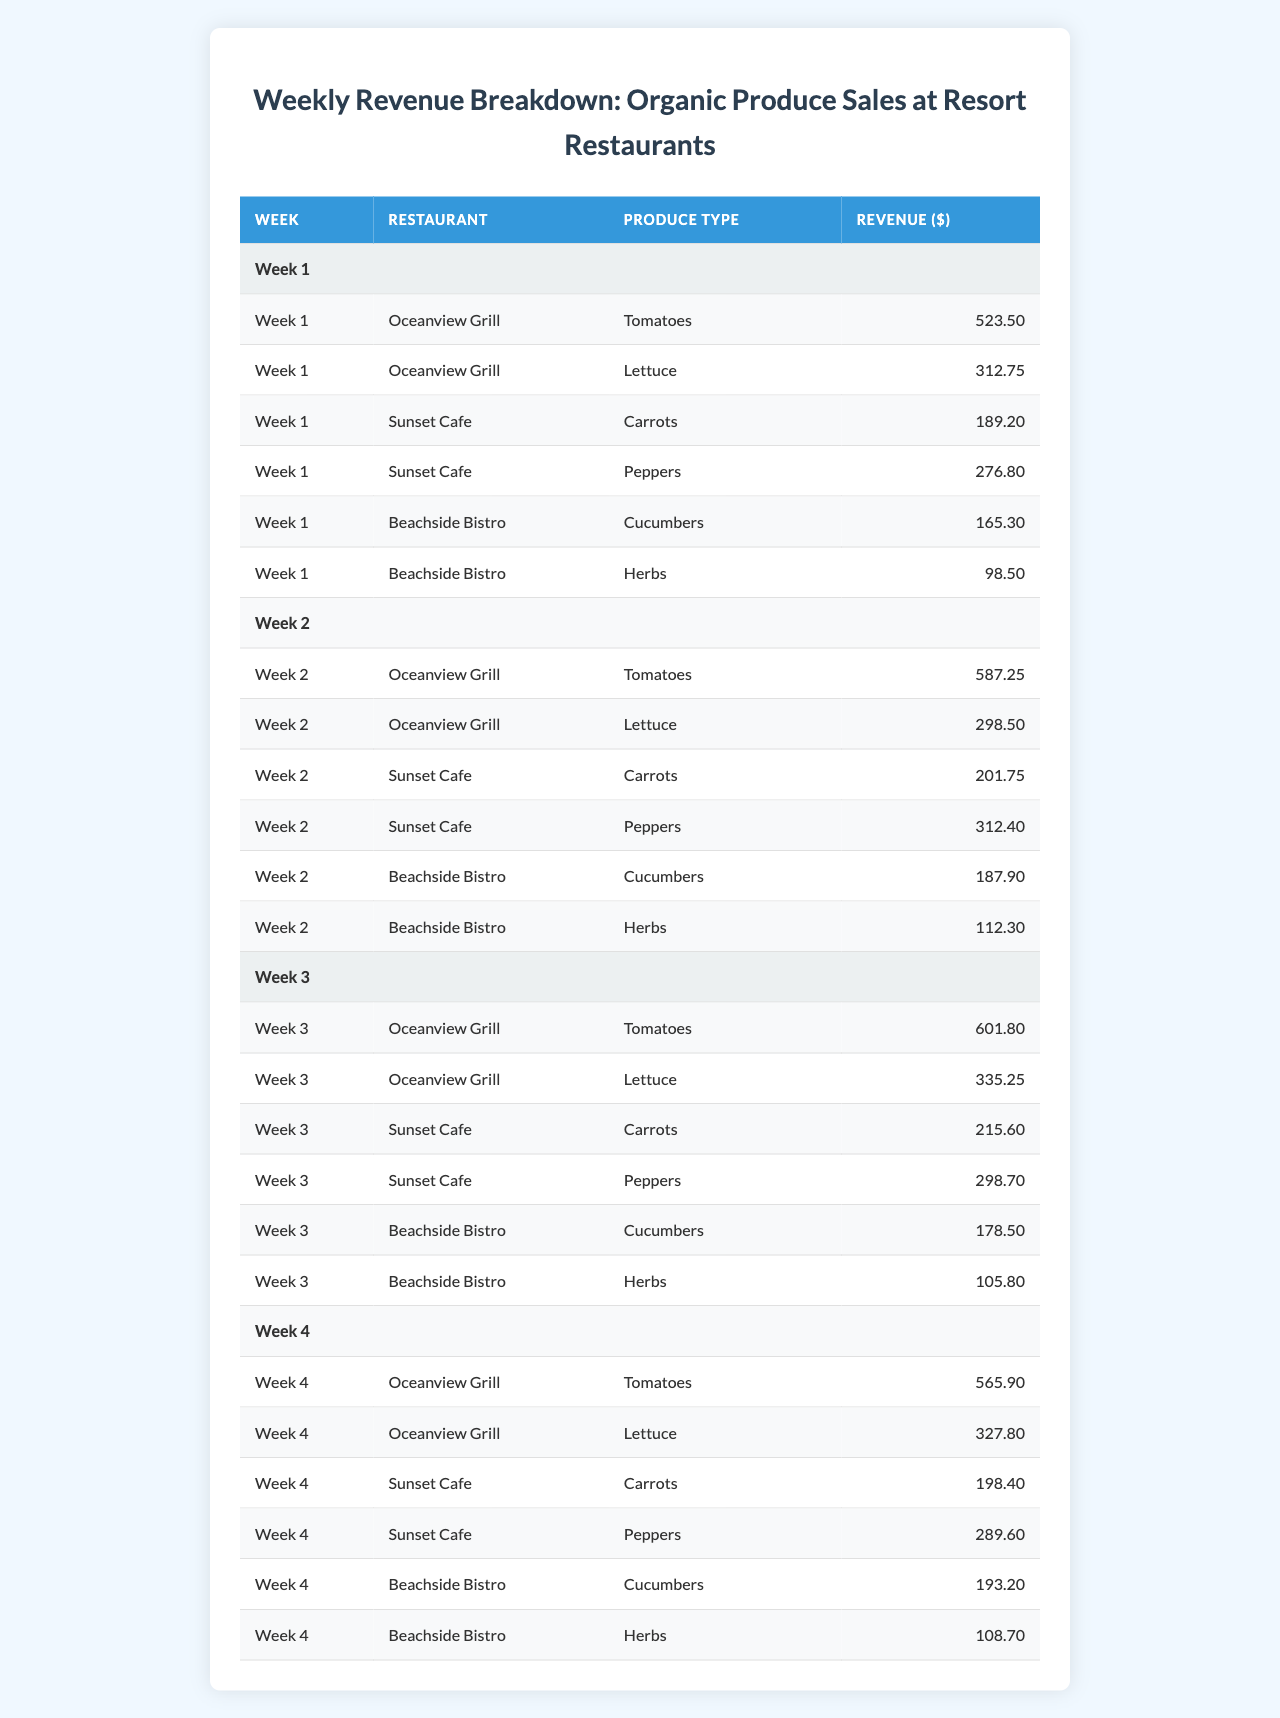What was the total revenue for organic tomatoes across all restaurants in Week 1? In Week 1, the revenue for tomatoes is listed under the Oceanview Grill only, which is $523.50. Therefore, the total revenue for organic tomatoes in Week 1 is $523.50.
Answer: $523.50 Which restaurant generated the highest revenue from organic produce in Week 2? In Week 2, the revenues for each restaurant are as follows: Oceanview Grill - $587.25 + $298.50, Sunset Cafe - $201.75 + $312.40, Beachside Bistro - $187.90 + $112.30. By calculating these, Oceanview Grill has the highest revenue of $885.75.
Answer: Oceanview Grill What is the average revenue generated from organic lettuce sales over the four weeks? The revenues for organic lettuce over the four weeks are as follows: Week 1 - $312.75, Week 2 - $298.50, Week 3 - $335.25, Week 4 - $327.80. Summing these gives $1274.30. Dividing by 4 weeks results in an average of $318.58.
Answer: $318.58 Did Beachside Bistro make more than $200 in revenue from organic cucumbers in Week 3? In Week 3, Beachside Bistro made $178.50 from cucumbers, which is less than $200. Therefore, the answer is no.
Answer: No What was the total organic produce revenue across all restaurants for Week 4? The total revenue for Week 4 can be calculated by summing all entries: Oceanview Grill ($565.90 + $327.80) + Sunset Cafe ($198.40 + $289.60) + Beachside Bistro ($193.20 + $108.70) = $1655.70.
Answer: $1655.70 Which produce type had the lowest revenue in Week 1? In Week 1, the revenues for different produce types were: Tomatoes ($523.50), Lettuce ($312.75), Carrots ($189.20), Peppers ($276.80), Cucumbers ($165.30), and Herbs ($98.50). The lowest revenue is from Herbs at $98.50.
Answer: Herbs What is the difference in revenue from organic carrots between Week 1 and Week 4? The revenue for organic carrots in Week 1 is $189.20 and in Week 4 is $198.40. The difference is calculated as $198.40 - $189.20 = $9.20.
Answer: $9.20 Which restaurant had consistent growth in tomato sales over the four weeks? By looking at the data: Oceanview Grill's tomato sales for the weeks are: Week 1 - $523.50, Week 2 - $587.25, Week 3 - $601.80, Week 4 - $565.90 shows an increase until Week 3 but a decrease in Week 4. So, there wasn't a consistent growth across all four weeks.
Answer: No What percentage of the total revenue from organic produce was made by Sunset Cafe in Week 2? Sunset Cafe's total revenue in Week 2 is $201.75 (Carrots) + $312.40 (Peppers) = $514.15. The total revenue across all restaurants for Week 2 is $885.75 (Oceanview) + $514.15 + $300.20 (Bistro) = $1700. The percentage is then ($514.15 / $1700) * 100 = 30.83%.
Answer: 30.83% Was the revenue from organic herbs always lower than $100 across all weeks? Looking at weekly data for organic herbs: Week 1 - $98.50, Week 2 - $112.30, Week 3 - $105.80, Week 4 - $108.70 shows that in Week 2, the revenue exceeded $100. Therefore, the statement is false.
Answer: No 